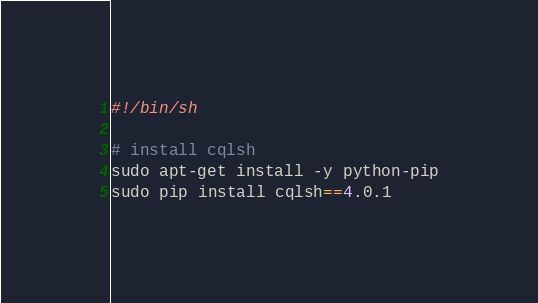<code> <loc_0><loc_0><loc_500><loc_500><_Bash_>#!/bin/sh

# install cqlsh
sudo apt-get install -y python-pip
sudo pip install cqlsh==4.0.1
</code> 